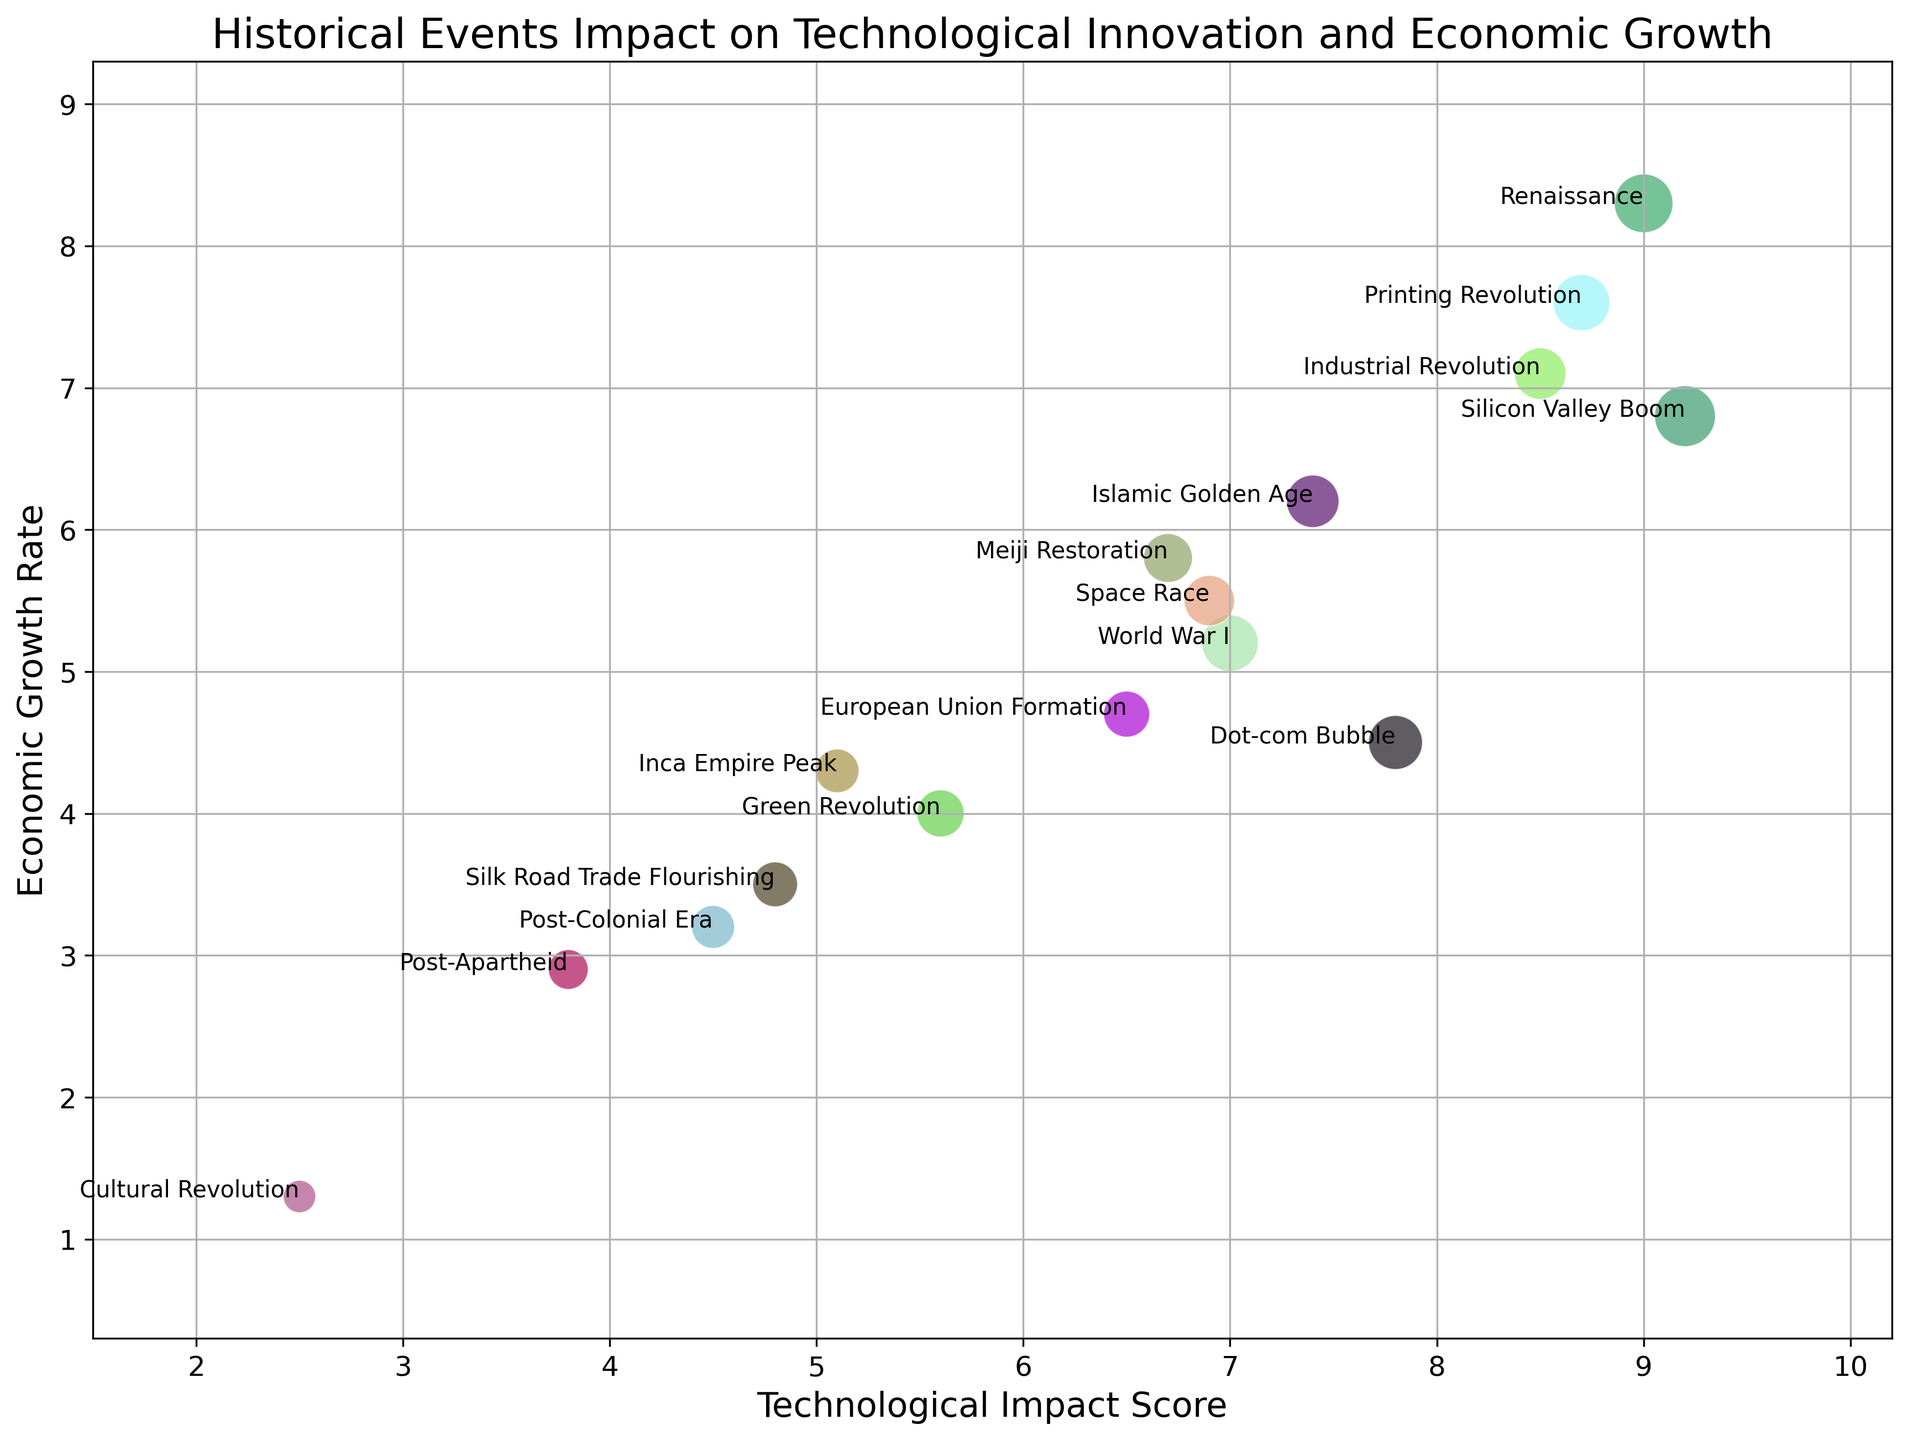Which historical event has the highest Technological Impact Score and what is its score? By looking at the x-axis which represents the Technological Impact Score, the Silicon Valley Boom has the highest score at 9.2.
Answer: Silicon Valley Boom, 9.2 Which region’s event marked around the 20th century shows the lowest economic growth rate and what is its rate? Focusing on events around the 20th century on the y-axis for Economic Growth Rate, the Cultural Revolution in Asia during 1966 has the lowest rate at 1.3.
Answer: Asia, 1.3 What is the sum of the Economic Growth Rates for events in North America? Add up the growth rates of all North American events: Industrial Revolution (7.1), Dot-com Bubble (4.5), Space Race (5.5), and Silicon Valley Boom (6.8). So, 7.1 + 4.5 + 5.5 + 6.8 = 23.9.
Answer: 23.9 Which event has a greater Economic Growth Rate, the Printing Revolution in Europe or the Meiji Restoration in Asia? By comparing these events on the y-axis, the Printing Revolution in Europe has a growth rate of 7.6, while the Meiji Restoration in Asia has 5.8. The Printing Revolution has a greater rate.
Answer: Printing Revolution Which region's events have the highest average Technological Impact Score, and what are the events involved? Compute average Tech Impact Score for each to find North America: (8.5 + 7.8 + 6.9 + 9.2)/4 = 8.1, Europe: (7.0 + 6.5 + 9.0 + 8.7)/4 = 7.8, etc. North America has the highest average.
Answer: North America Does the size of the bubble for the Space Race suggest a larger or smaller relative impact compared to the European Union Formation? The bubble size on the plot indicates relative impact; the Space Race has a bubble size of 48, whereas the European Union Formation has 40. The Space Race suggests a larger impact.
Answer: Larger What is the total bubble size for all events in Asia? Add the bubble sizes for all Asian events: Meiji Restoration (45), Cultural Revolution (20), Green Revolution (42), Silk Road Trade Flourishing (38). Total = 45 + 20 + 42 + 38 = 145.
Answer: 145 What are the regions and their respective events with an Economic Growth Rate above 6.0? By looking above the 6.0 mark on the y-axis: North America (Industrial Revolution, Silicon Valley Boom), Europe (Renaissance, Printing Revolution), Middle East (Islamic Golden Age).
Answer: North America, Europe, Middle East Which event occurring before 1500 has the highest Economic Growth Rate and what is its rate? Look for events before 1500 on the y-axis and compare rates: Renaissance in Europe has the highest at 8.3.
Answer: Renaissance, 8.3 Compare and determine the average Economic Growth Rate for events in Europe and Asia. Europe: (5.2+4.7+8.3+7.6)/4=6.45, Asia: (5.8+1.3+4.0+3.5)/4= 3.65. Europe has the higher average.
Answer: Europe: 6.45, Asia: 3.65 